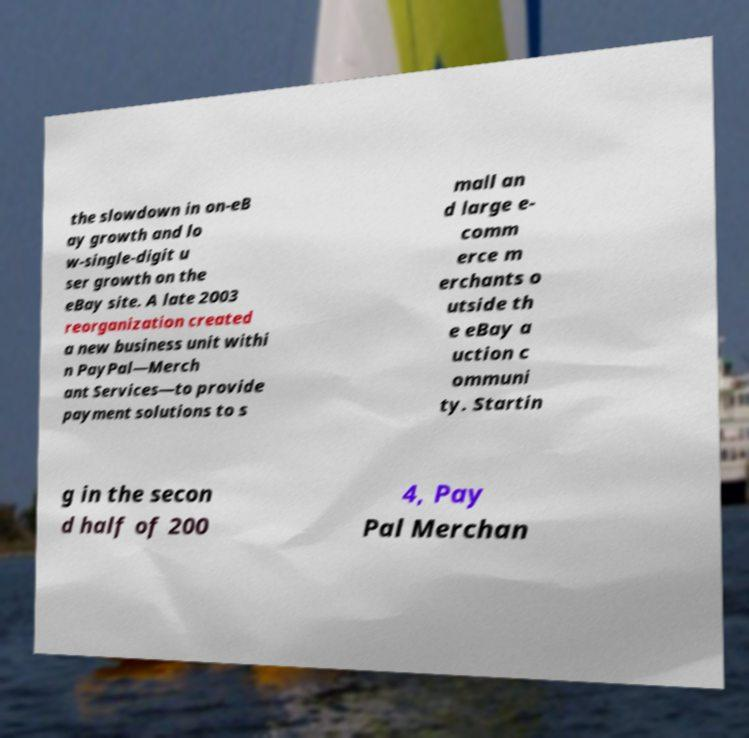Could you assist in decoding the text presented in this image and type it out clearly? the slowdown in on-eB ay growth and lo w-single-digit u ser growth on the eBay site. A late 2003 reorganization created a new business unit withi n PayPal—Merch ant Services—to provide payment solutions to s mall an d large e- comm erce m erchants o utside th e eBay a uction c ommuni ty. Startin g in the secon d half of 200 4, Pay Pal Merchan 